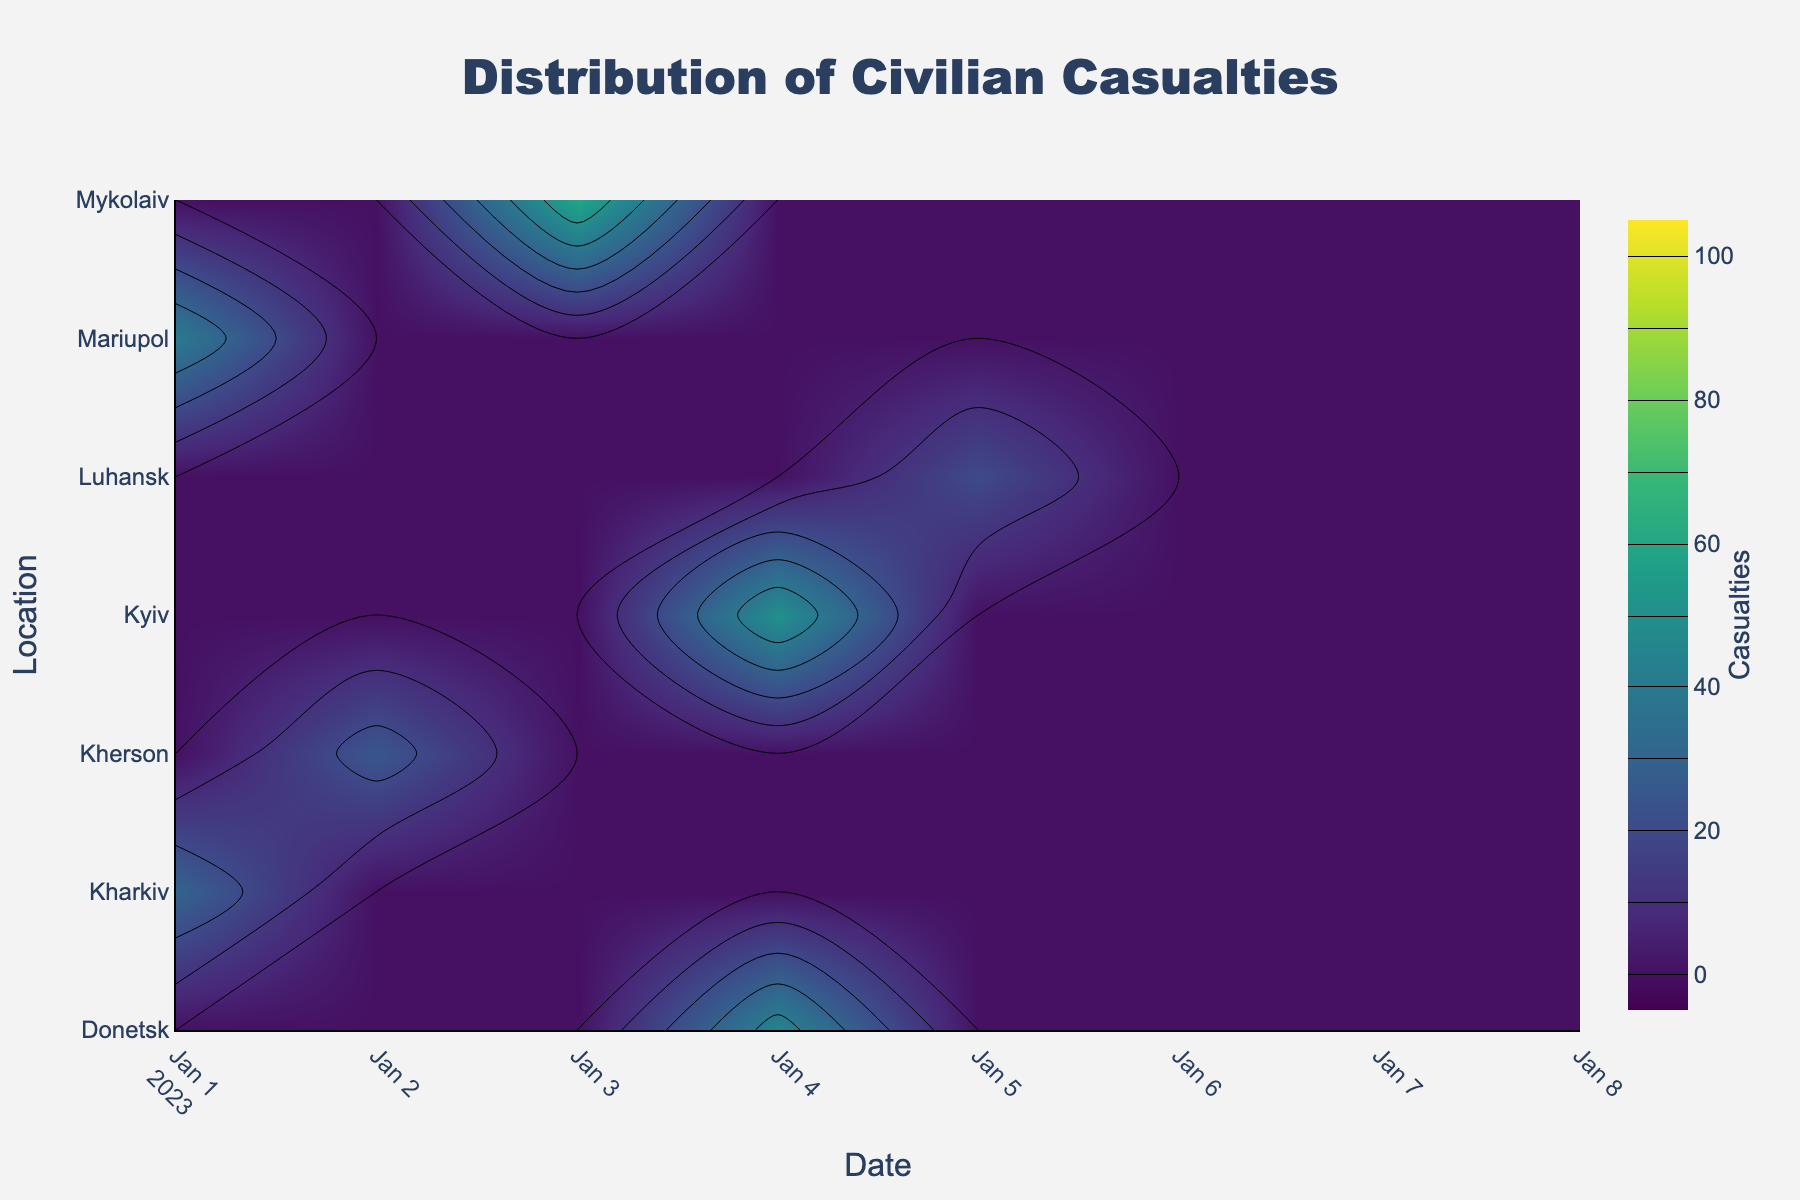What's the title of the plot? The title of the plot is displayed at the top center of the figure. It provides a brief description of the overall content of the plot.
Answer: Distribution of Civilian Casualties Which geographic location shows the highest number of casualties on January 26, 2023? To find this, locate January 26, 2023, on the x-axis, and then identify the location with the highest contour value along this vertical line. The color gradient will indicate the highest number of casualties.
Answer: Kherson What is the range of casualties depicted in the colorbar? Look at the colorbar on the right side of the plot, which provides the range and increments of the values illustrated by the color gradient.
Answer: 0 to 100 Which date shows the highest casualty in Kyiv? By tracing the values along the y-coordinate for Kyiv, you identify the date where the highest contour level (darkest color) occurs.
Answer: January 24, 2023 What is the trend of casualties in Donetsk throughout the observed dates? To determine this, follow the contour values for Donetsk across the timeline on the x-axis. Look for increases, decreases, and any patterns in the gradient colors.
Answer: Increasing overall Which location shows the most significant increase in casualties between January 14 and January 24, 2023? Identify the colors on January 14 and compare with January 24. Look for the largest color change, indicating the most significant increase in casualties.
Answer: Kyiv Comparing Kyiv and Kharkiv, which location had more fluctuations in casualties over the time period? Examine both the contour levels for Kyiv and Kharkiv. More fluctuations will be shown by frequent changes between higher and lower values.
Answer: Kyiv On which date did Mykolaiv see its highest casualties? Trace along the x-axis for the y-coordinate corresponding to Mykolaiv and identify the peak contour level on that line.
Answer: January 28, 2023 Is there any day with zero casualties recorded in any of the locations? Look for any spots along the x-axis where the contour value is zero (lightest color) across all geographic locations.
Answer: No Which locations had the highest casualties on January 16, 2023? Refer to January 16, 2023, on the x-axis and identify the location with the darkest contour color on that vertical line.
Answer: Kherson Which location consistently shows lower casualties over the observed period? Observe the contour colors for all dates and compare among the locations. Consistently low casualties are indicated by lighter colors.
Answer: Luhansk 